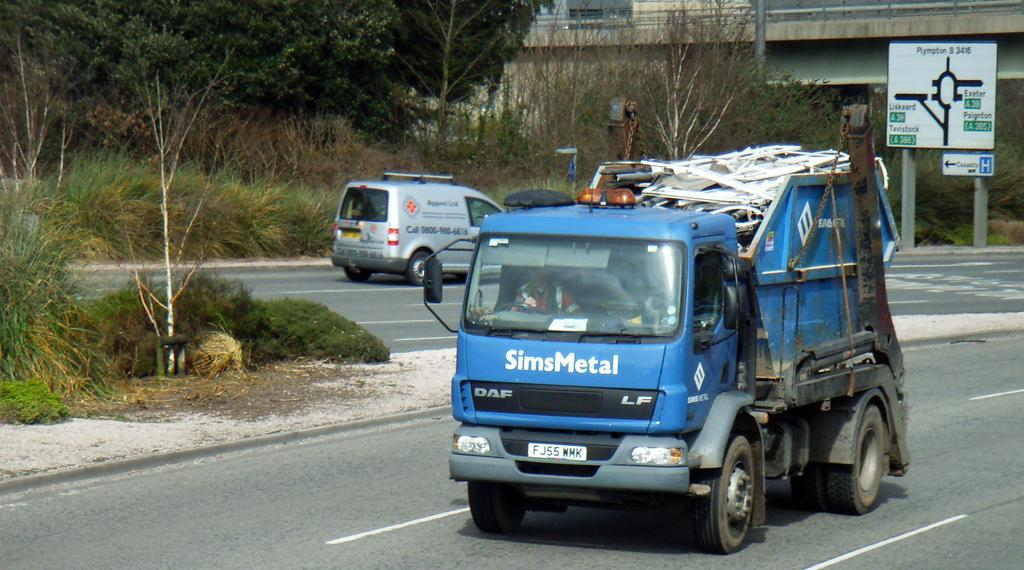How many vehicles can be seen on the road in the image? There are two vehicles on the road in the image. What can be seen in the background of the image? Trees are visible in the image. What is the color of the board in the image? The board in the image is white. What type of sock is hanging on the tree in the image? There is no sock present in the image; it only features vehicles, trees, and a white color board. 